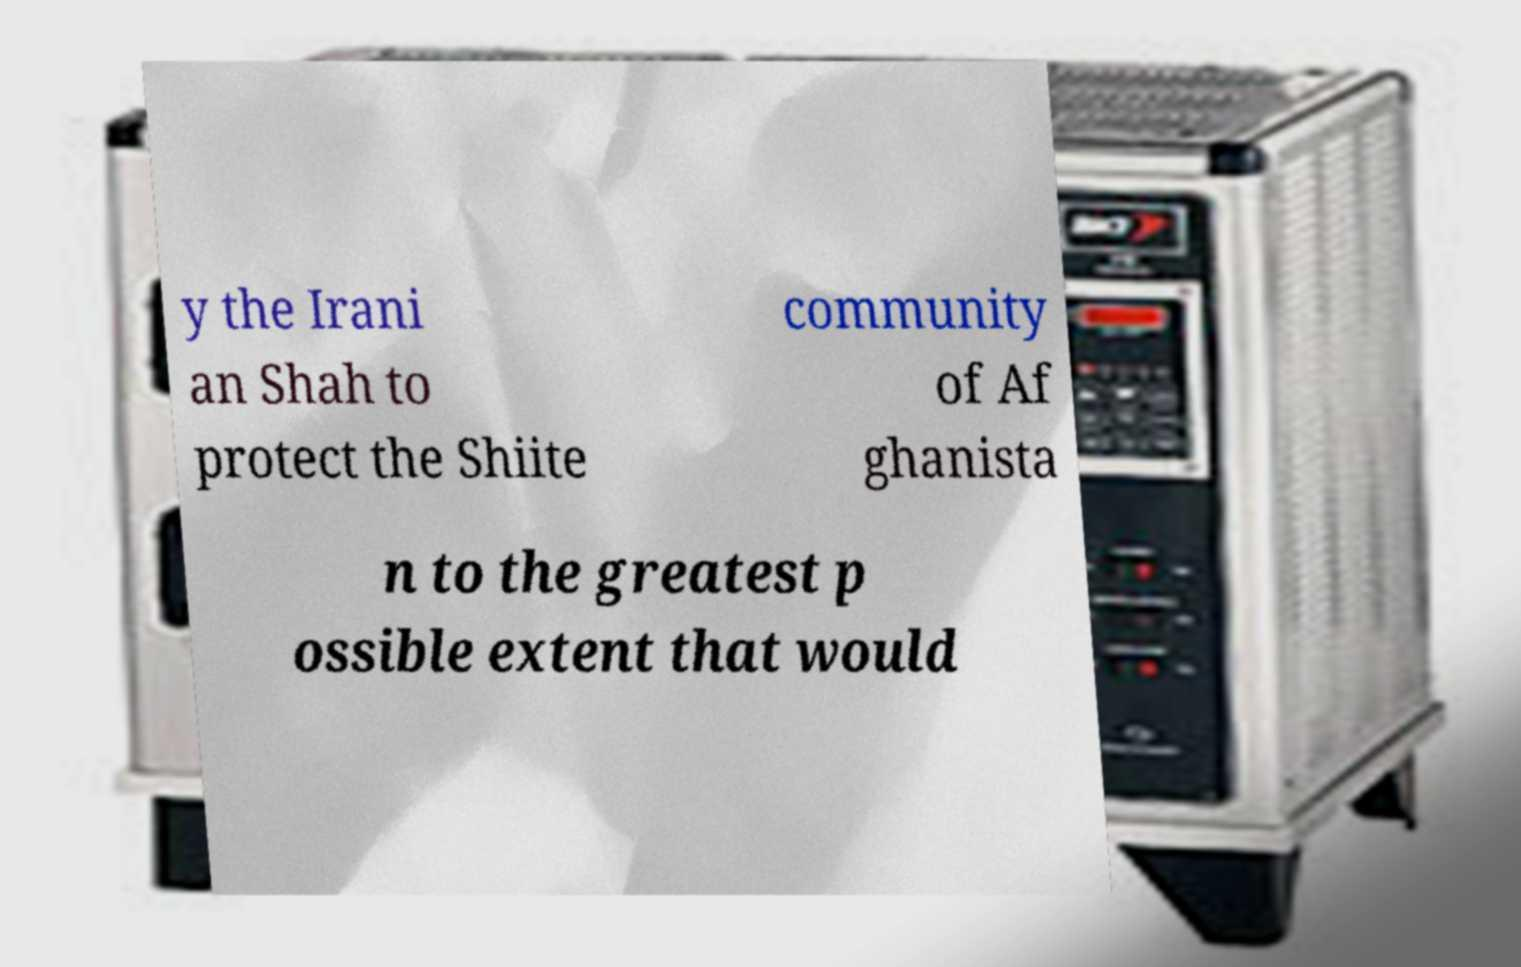Please read and relay the text visible in this image. What does it say? y the Irani an Shah to protect the Shiite community of Af ghanista n to the greatest p ossible extent that would 